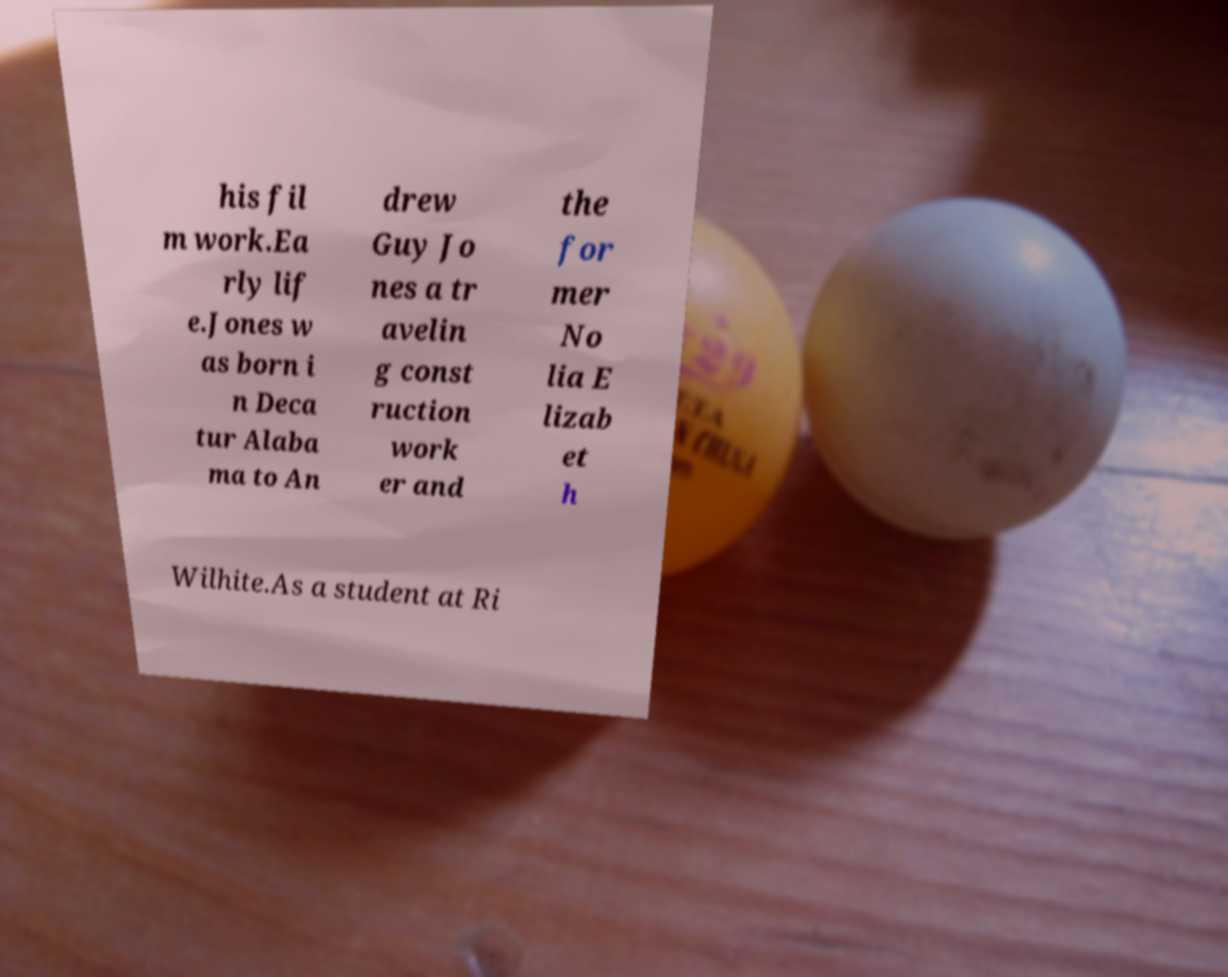I need the written content from this picture converted into text. Can you do that? his fil m work.Ea rly lif e.Jones w as born i n Deca tur Alaba ma to An drew Guy Jo nes a tr avelin g const ruction work er and the for mer No lia E lizab et h Wilhite.As a student at Ri 